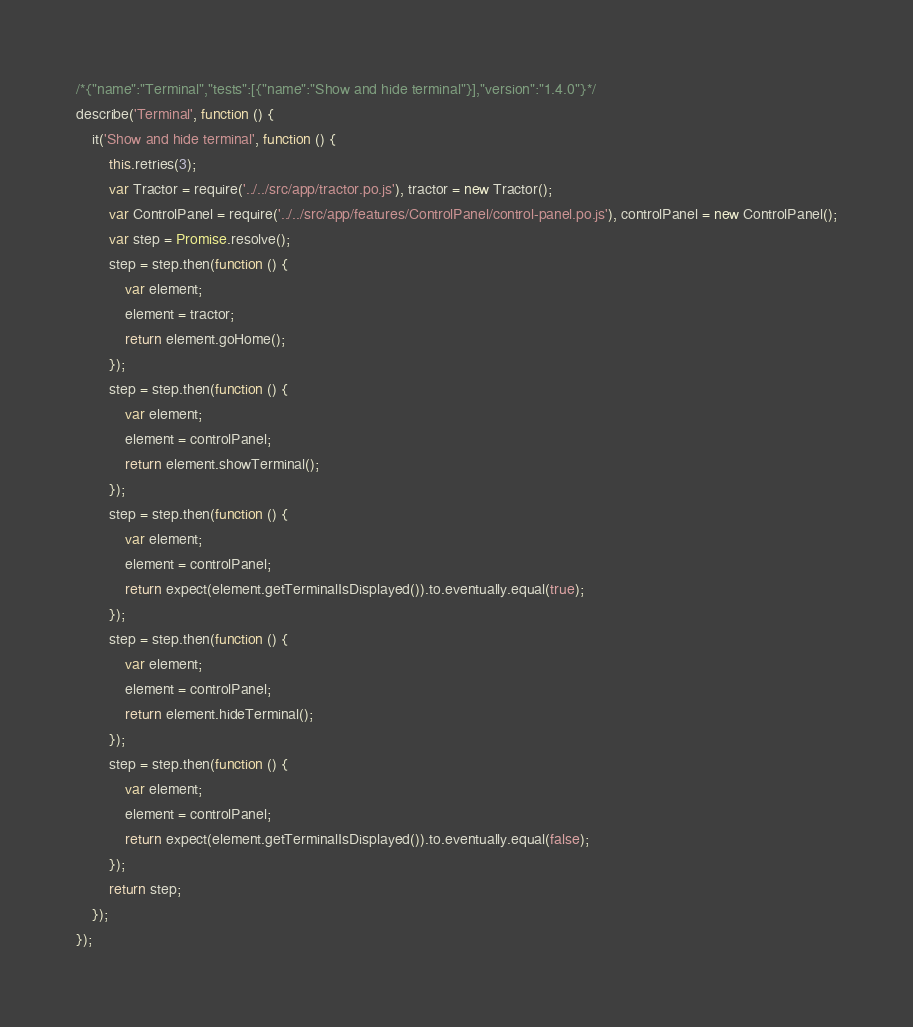Convert code to text. <code><loc_0><loc_0><loc_500><loc_500><_JavaScript_>/*{"name":"Terminal","tests":[{"name":"Show and hide terminal"}],"version":"1.4.0"}*/
describe('Terminal', function () {
    it('Show and hide terminal', function () {
        this.retries(3);
        var Tractor = require('../../src/app/tractor.po.js'), tractor = new Tractor();
        var ControlPanel = require('../../src/app/features/ControlPanel/control-panel.po.js'), controlPanel = new ControlPanel();
        var step = Promise.resolve();
        step = step.then(function () {
            var element;
            element = tractor;
            return element.goHome();
        });
        step = step.then(function () {
            var element;
            element = controlPanel;
            return element.showTerminal();
        });
        step = step.then(function () {
            var element;
            element = controlPanel;
            return expect(element.getTerminalIsDisplayed()).to.eventually.equal(true);
        });
        step = step.then(function () {
            var element;
            element = controlPanel;
            return element.hideTerminal();
        });
        step = step.then(function () {
            var element;
            element = controlPanel;
            return expect(element.getTerminalIsDisplayed()).to.eventually.equal(false);
        });
        return step;
    });
});</code> 